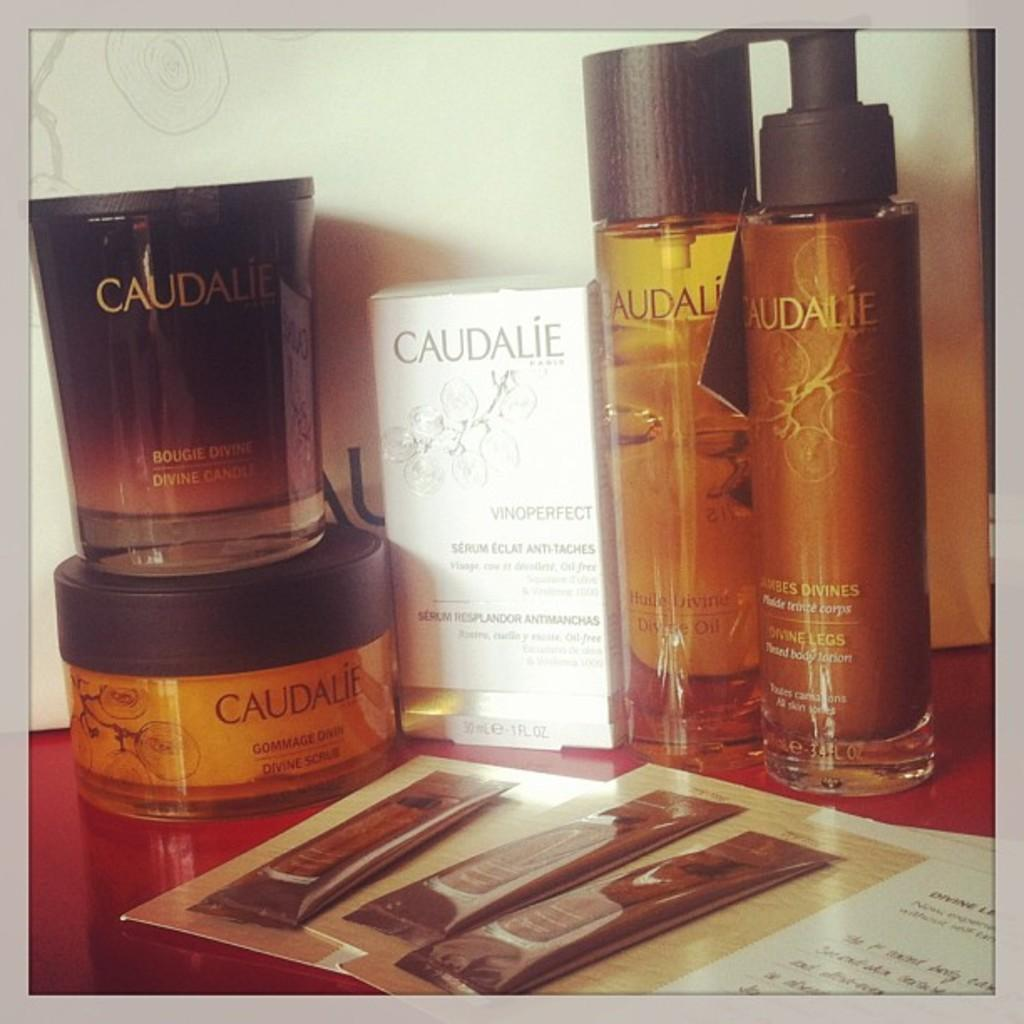What type of product is visible in the image? There is a face wash cream in the image. What other beauty products can be seen in the image? There are bottles of perfume in the image. Are there any other skincare or cosmetic products in the image? Yes, there are packets of cream in the image. Where are these products located? These items are placed on a table. What type of seed is being planted by the wren in the image? There is no seed or wren present in the image; it features beauty products placed on a table. 